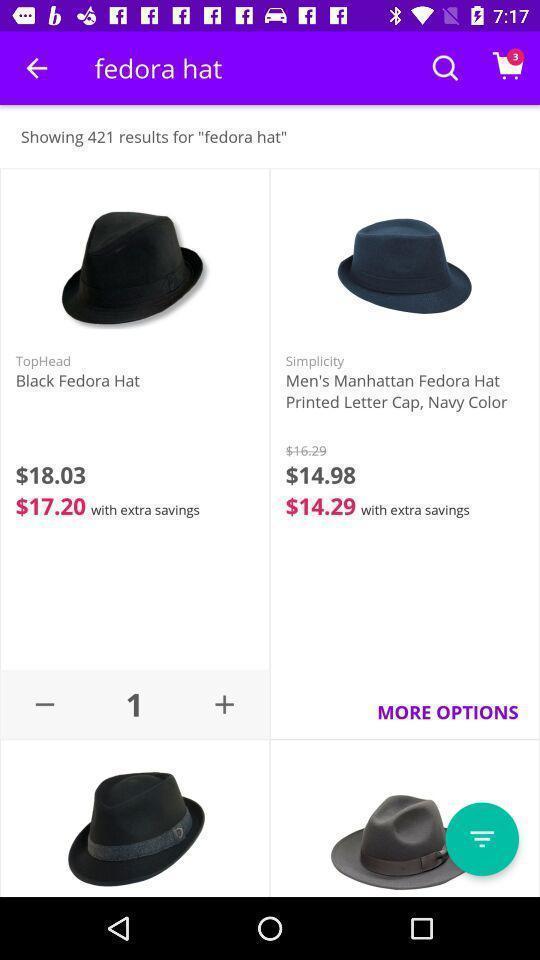Summarize the main components in this picture. Screen displaying results for hat in an shopping application. 